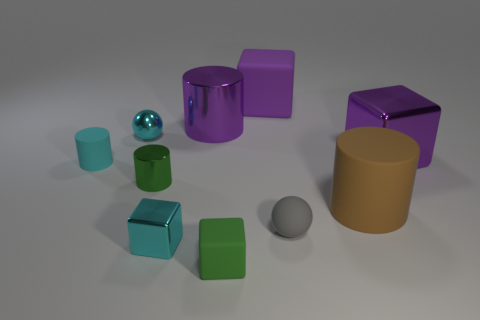Subtract all tiny rubber blocks. How many blocks are left? 3 Subtract all green cylinders. How many cylinders are left? 3 Subtract 4 cylinders. How many cylinders are left? 0 Add 1 large cubes. How many large cubes are left? 3 Add 3 small blue rubber cubes. How many small blue rubber cubes exist? 3 Subtract 1 purple cylinders. How many objects are left? 9 Subtract all cylinders. How many objects are left? 6 Subtract all brown cylinders. Subtract all cyan balls. How many cylinders are left? 3 Subtract all brown spheres. How many green blocks are left? 1 Subtract all big gray rubber spheres. Subtract all big cylinders. How many objects are left? 8 